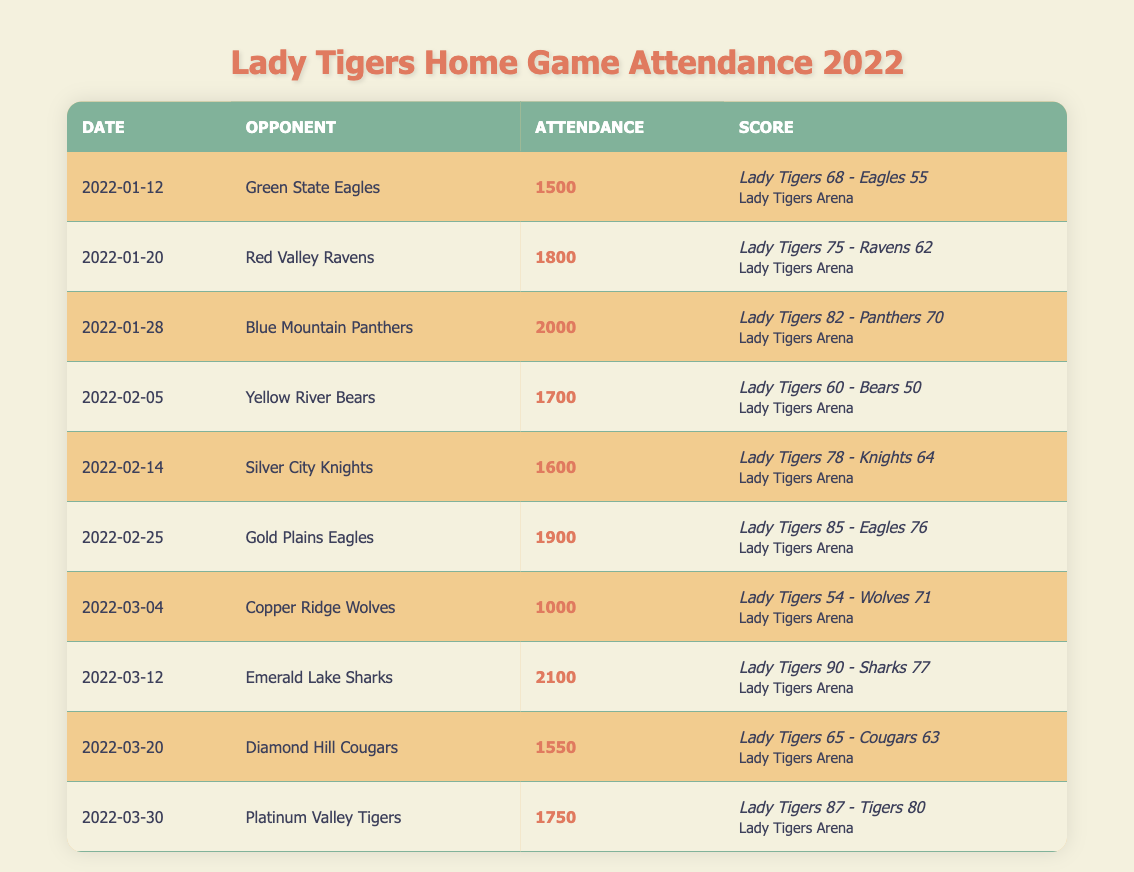What was the highest attendance for a Lady Tigers home game in 2022? The table indicates attendance figures for each game. By scanning through the attendance values, the highest attendance is found on March 12, 2022, with 2100 fans.
Answer: 2100 What was the lowest attendance during the Lady Tigers home games in the 2022 season? Looking at the attendance values listed in the table, the lowest attendance is 1000 on March 4, 2022, against the Copper Ridge Wolves.
Answer: 1000 How many games did the Lady Tigers play at home in January 2022? The table shows three home games in January: January 12 against Green State Eagles, January 20 against Red Valley Ravens, and January 28 against Blue Mountain Panthers.
Answer: 3 What was the average attendance for the Lady Tigers home games in February 2022? The attendance for February games is: 1700 (Feb 5) + 1600 (Feb 14) + 1900 (Feb 25) = 5200. There are 3 games, so the average attendance is 5200/3 = approximately 1733.33.
Answer: 1733 Did the Lady Tigers win against the Copper Ridge Wolves? In the game's score on March 4, 2022, the Lady Tigers scored 54 while the Wolves scored 71, indicating the Lady Tigers lost this game.
Answer: No How many games did the Lady Tigers have an attendance of over 1800? By reviewing the attendance figures, the games with over 1800 attendance are: 1800 (Jan 20), 2000 (Jan 28), 1900 (Feb 25), 2100 (Mar 12). This totals to 4 games.
Answer: 4 What was the total attendance for all Lady Tigers home games in the 2022 season? Adding the attendance figures together: 1500 + 1800 + 2000 + 1700 + 1600 + 1900 + 1000 + 2100 + 1550 + 1750 results in 15100.
Answer: 15100 Which opponent had the least number of fans in attendance when they played against the Lady Tigers? The opponent with the least attendance is the Copper Ridge Wolves, with only 1000 fans attending on March 4, 2022.
Answer: Copper Ridge Wolves How many games resulted in a score of over 80 points for the Lady Tigers? The games where the Lady Tigers scored over 80 points are: January 28 (82), February 25 (85), and March 12 (90), totaling 3 games.
Answer: 3 What was the attendance difference between the game against the Emerald Lake Sharks and the game against the Gold Plains Eagles? The attendance for each game was 2100 (Sharks) and 1900 (Eagles). The difference is 2100 - 1900 = 200.
Answer: 200 